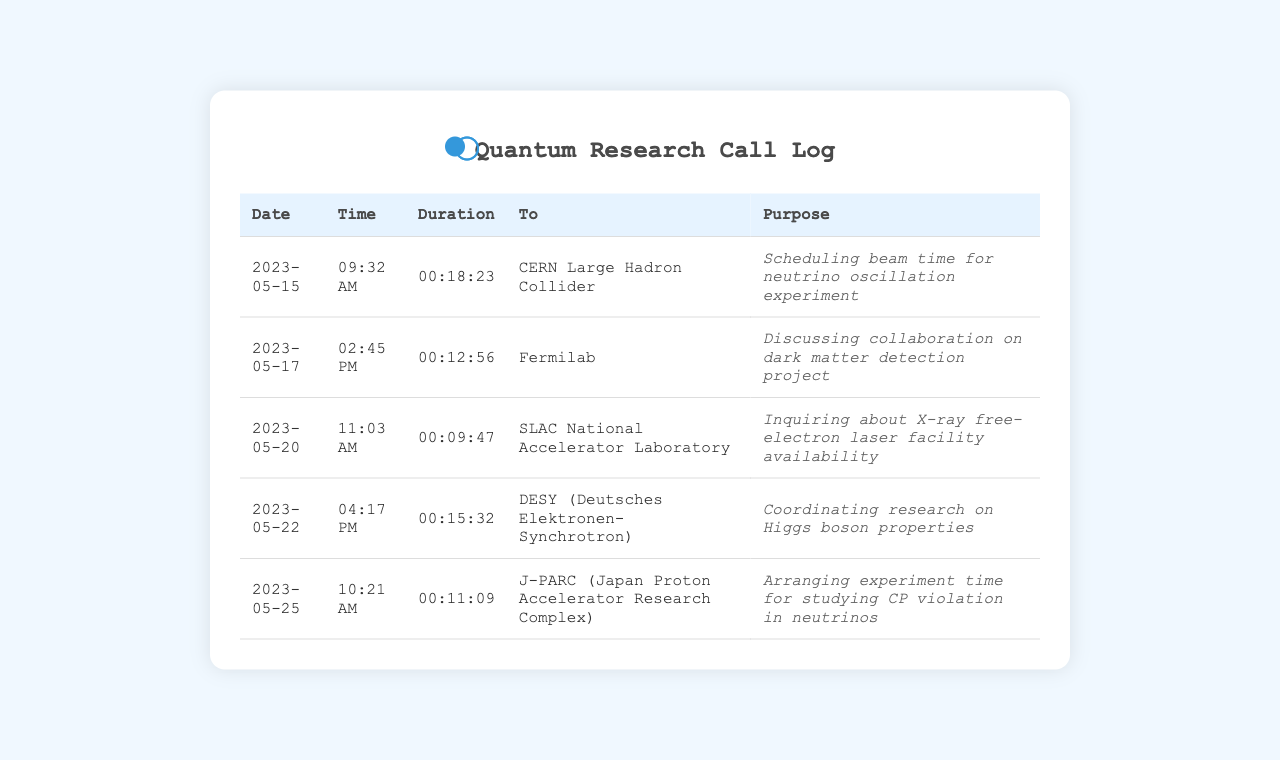What is the date of the call to CERN? The specific date of the call to CERN is mentioned in the records, which is May 15, 2023.
Answer: May 15, 2023 What is the duration of the call to Fermilab? The duration of the call to Fermilab is indicated, which is 12 minutes and 56 seconds.
Answer: 00:12:56 What facility was contacted on May 20? The facility contacted on May 20 is listed in the document as SLAC National Accelerator Laboratory.
Answer: SLAC National Accelerator Laboratory How long was the call to J-PARC? The call duration to J-PARC is noted in the document, which is 11 minutes and 9 seconds.
Answer: 00:11:09 What was the purpose of the call to DESY? The purpose of the call to DESY is stated explicitly, focusing on coordinating research related to Higgs boson properties.
Answer: Coordinating research on Higgs boson properties Which facility is concerned with dark matter detection? The document mentions Fermilab in relation to discussion on a project about dark matter detection.
Answer: Fermilab Which call had the longest duration? To determine the longest duration, one needs to compare the durations; the longest is for the call to CERN lasting 18 minutes and 23 seconds.
Answer: 00:18:23 How many calls are listed in the document? The number of calls can be counted from the table, which presents details for five different calls.
Answer: 5 What experimental topic was mentioned for the J-PARC call? The experimental topic mentioned during the call to J-PARC is studying CP violation in neutrinos.
Answer: Studying CP violation in neutrinos What was the main focus of the call to SLAC? The main focus of the call to SLAC was to inquire about the availability of the X-ray free-electron laser facility.
Answer: Inquiring about X-ray free-electron laser facility availability 